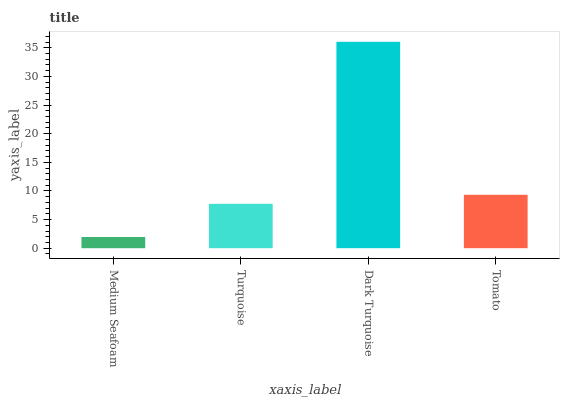Is Medium Seafoam the minimum?
Answer yes or no. Yes. Is Dark Turquoise the maximum?
Answer yes or no. Yes. Is Turquoise the minimum?
Answer yes or no. No. Is Turquoise the maximum?
Answer yes or no. No. Is Turquoise greater than Medium Seafoam?
Answer yes or no. Yes. Is Medium Seafoam less than Turquoise?
Answer yes or no. Yes. Is Medium Seafoam greater than Turquoise?
Answer yes or no. No. Is Turquoise less than Medium Seafoam?
Answer yes or no. No. Is Tomato the high median?
Answer yes or no. Yes. Is Turquoise the low median?
Answer yes or no. Yes. Is Turquoise the high median?
Answer yes or no. No. Is Medium Seafoam the low median?
Answer yes or no. No. 